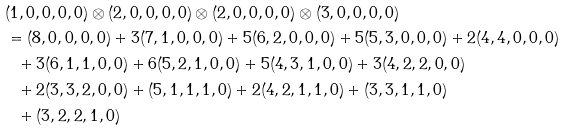<formula> <loc_0><loc_0><loc_500><loc_500>\ & ( 1 , 0 , 0 , 0 , 0 ) \otimes ( 2 , 0 , 0 , 0 , 0 ) \otimes ( 2 , 0 , 0 , 0 , 0 ) \otimes ( 3 , 0 , 0 , 0 , 0 ) \ \\ & = ( 8 , 0 , 0 , 0 , 0 ) + 3 ( 7 , 1 , 0 , 0 , 0 ) + 5 ( 6 , 2 , 0 , 0 , 0 ) + 5 ( 5 , 3 , 0 , 0 , 0 ) + 2 ( 4 , 4 , 0 , 0 , 0 ) \\ & \ \ + 3 ( 6 , 1 , 1 , 0 , 0 ) + 6 ( 5 , 2 , 1 , 0 , 0 ) + 5 ( 4 , 3 , 1 , 0 , 0 ) + 3 ( 4 , 2 , 2 , 0 , 0 ) \\ & \ \ + 2 ( 3 , 3 , 2 , 0 , 0 ) + ( 5 , 1 , 1 , 1 , 0 ) + 2 ( 4 , 2 , 1 , 1 , 0 ) + ( 3 , 3 , 1 , 1 , 0 ) \\ & \ \ + ( 3 , 2 , 2 , 1 , 0 )</formula> 